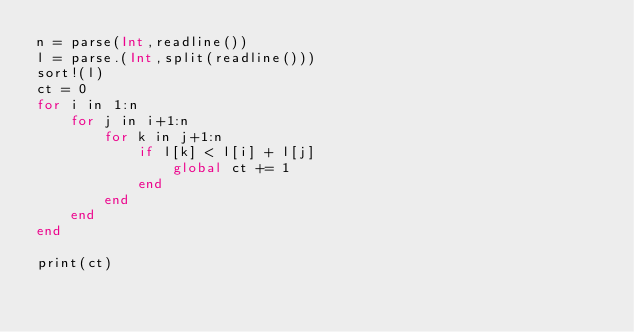<code> <loc_0><loc_0><loc_500><loc_500><_Julia_>n = parse(Int,readline())
l = parse.(Int,split(readline()))
sort!(l)
ct = 0
for i in 1:n
    for j in i+1:n
        for k in j+1:n
            if l[k] < l[i] + l[j]
                global ct += 1
            end
        end
    end
end

print(ct)
            </code> 